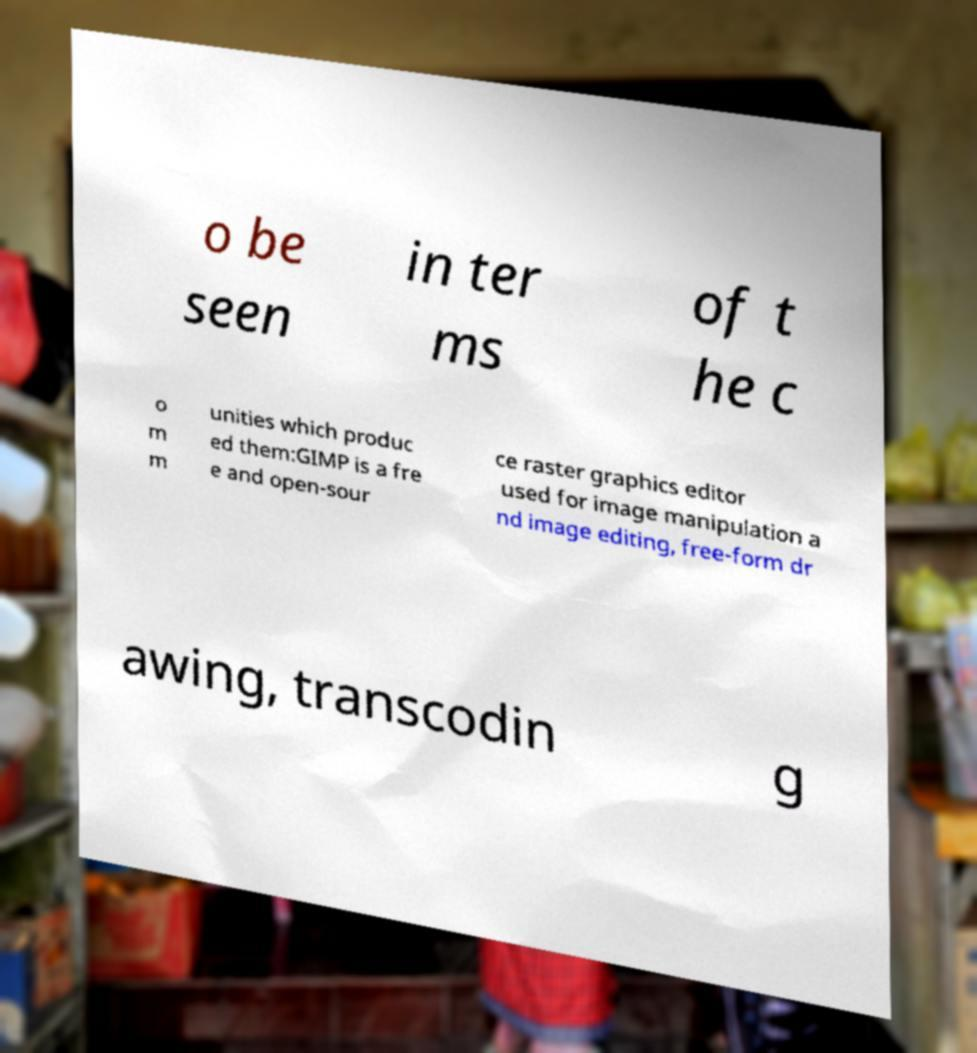What messages or text are displayed in this image? I need them in a readable, typed format. o be seen in ter ms of t he c o m m unities which produc ed them:GIMP is a fre e and open-sour ce raster graphics editor used for image manipulation a nd image editing, free-form dr awing, transcodin g 